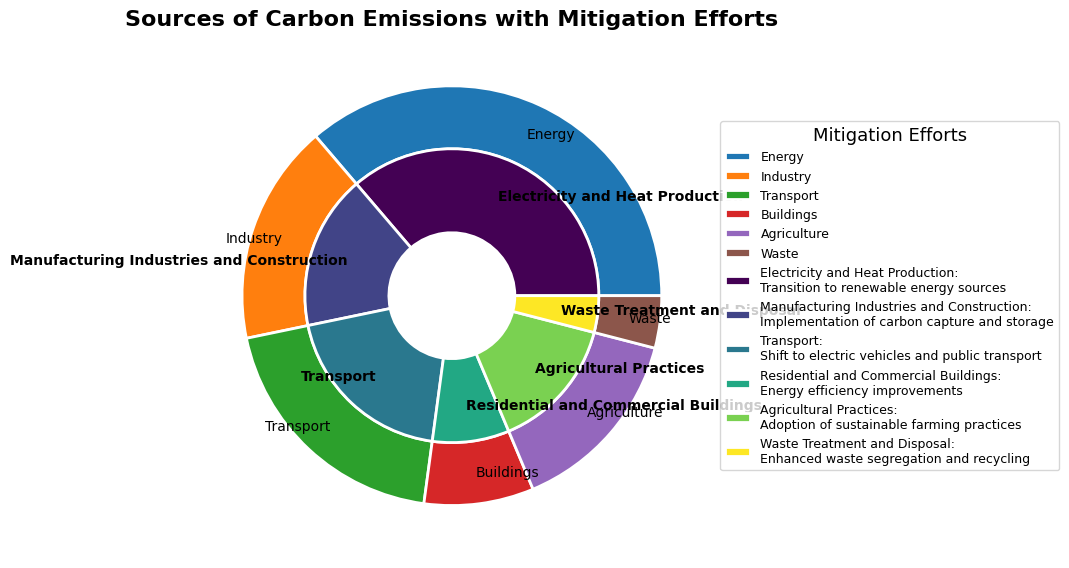What is the largest source of carbon emissions, and how much does it contribute? The figure shows the sectors as wedges in the outer pie chart. The sector labeled "Energy" is the largest wedge, representing "Electricity and Heat Production." The emissions from this sector are 13,201.9 Mt CO2e according to the data.
Answer: Energy, 13,201.9 Mt CO2e Which industry emits less carbon: Residential and Commercial Buildings or Waste Treatment and Disposal? By comparing the inner pie chart wedges labeled "Residential and Commercial Buildings" and "Waste Treatment and Disposal," it's evident that the wedge for "Waste Treatment and Disposal" is smaller. According to the data, "Residential and Commercial Buildings" emit 3,078.8 Mt CO2e, while "Waste Treatment and Disposal" emits 1,466.0 Mt CO2e.
Answer: Waste Treatment and Disposal What is the combined carbon emissions from Agricultural Practices and Transport industries? The inner pie chart shows wedges for "Agricultural Practices" and "Transport." The data indicates that "Agricultural Practices" emit 5,335.6 Mt CO2e and "Transport" emits 7,142.3 Mt CO2e. Adding these values: 5,335.6 + 7,142.3 = 12,477.9 Mt CO2e.
Answer: 12,477.9 Mt CO2e Which sector has the smallest wedge, and what mitigation effort is associated with it? The outer pie chart shows the smallest wedge for "Waste." The data indicates that the mitigation effort associated with "Waste Treatment and Disposal" is enhanced waste segregation and recycling.
Answer: Waste, Enhanced waste segregation and recycling How do manufacturing industries rank in terms of carbon emissions compared to transport? Comparing the wedges within the inner pie chart labeled "Manufacturing Industries and Construction" and "Transport," the data shows that "Manufacturing Industries and Construction" emits 6,193.6 Mt CO2e, while "Transport" emits 7,142.3 Mt CO2e. Transport emits more carbon emissions than manufacturing industries.
Answer: Transport emits more What percentage of total carbon emissions is contributed by the Residential and Commercial Buildings sector? The total emissions are the sum of all sectors’ emissions: 13,201.9 (Energy) + 6,193.6 (Industry) + 7,142.3 (Transport) + 3,078.8 (Buildings) + 5,335.6 (Agriculture) + 1,466.0 (Waste) = 36,418.2 Mt CO2e. The Residential and Commercial Buildings sector emits 3,078.8 Mt CO2e. The percentage is thus (3,078.8 / 36,418.2) × 100 ≈ 8.45%.
Answer: Approximately 8.45% Which industries fall under the sector with the second-largest carbon emissions wedge, and what are their individual emissions contributions? The second-largest wedge in the outer pie chart is Transport. The inner pie chart indicates "Transport" as the industry under this sector, emitting 7,142.3 Mt CO2e.
Answer: Transport, 7,142.3 Mt CO2e 